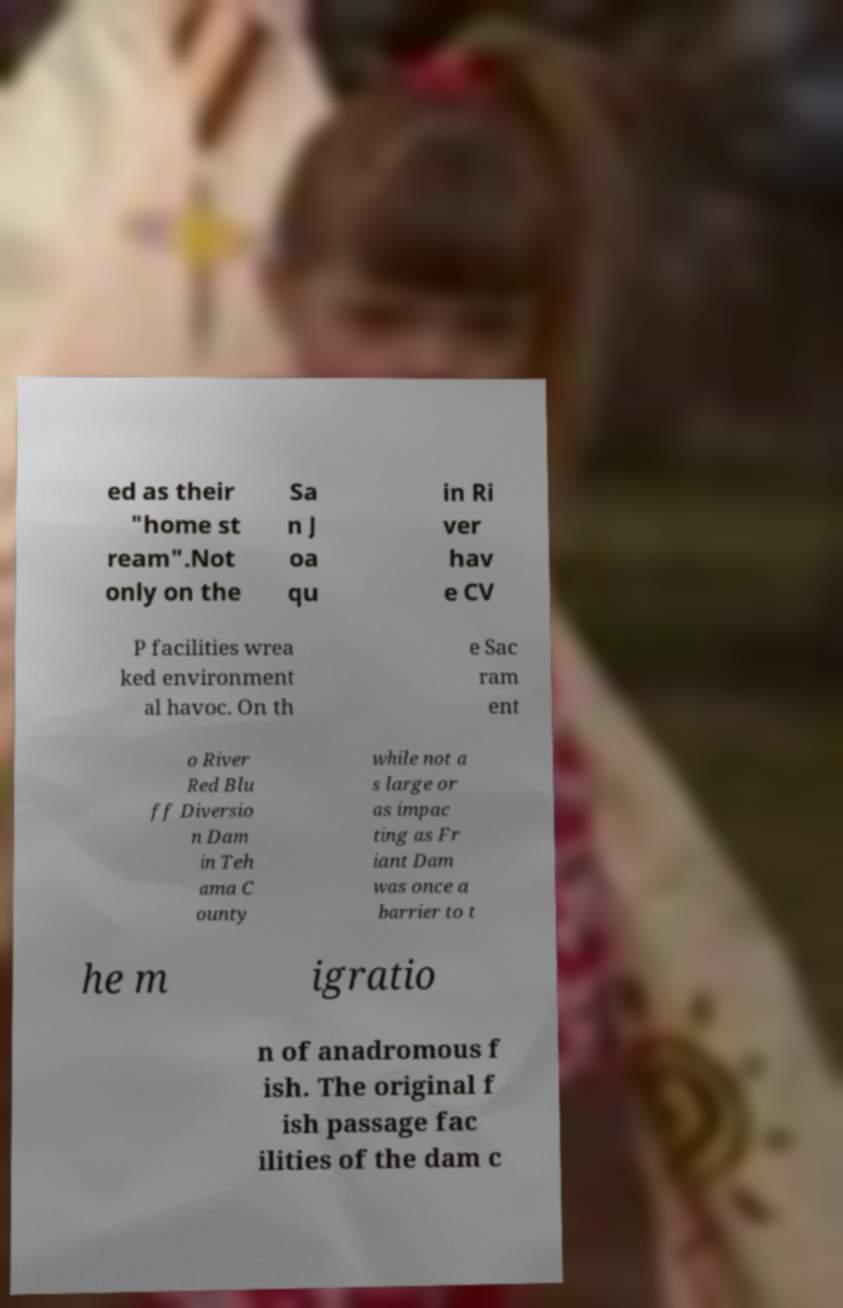Could you extract and type out the text from this image? ed as their "home st ream".Not only on the Sa n J oa qu in Ri ver hav e CV P facilities wrea ked environment al havoc. On th e Sac ram ent o River Red Blu ff Diversio n Dam in Teh ama C ounty while not a s large or as impac ting as Fr iant Dam was once a barrier to t he m igratio n of anadromous f ish. The original f ish passage fac ilities of the dam c 